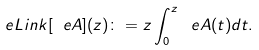Convert formula to latex. <formula><loc_0><loc_0><loc_500><loc_500>\ e L i n k [ \ e A ] ( z ) \colon = z \int _ { 0 } ^ { z } \ e A ( t ) d t .</formula> 